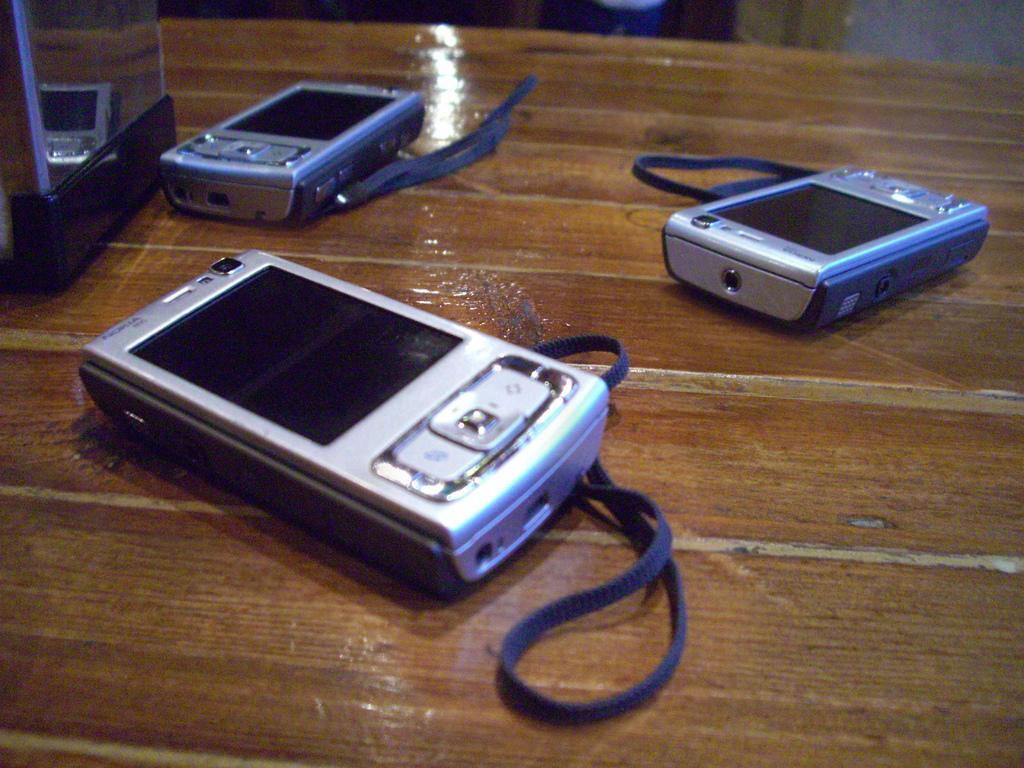Please provide a concise description of this image. In this image we can see cameras on the table. 